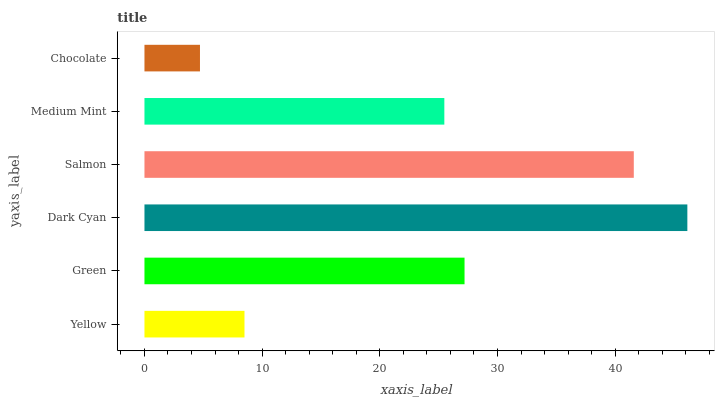Is Chocolate the minimum?
Answer yes or no. Yes. Is Dark Cyan the maximum?
Answer yes or no. Yes. Is Green the minimum?
Answer yes or no. No. Is Green the maximum?
Answer yes or no. No. Is Green greater than Yellow?
Answer yes or no. Yes. Is Yellow less than Green?
Answer yes or no. Yes. Is Yellow greater than Green?
Answer yes or no. No. Is Green less than Yellow?
Answer yes or no. No. Is Green the high median?
Answer yes or no. Yes. Is Medium Mint the low median?
Answer yes or no. Yes. Is Salmon the high median?
Answer yes or no. No. Is Yellow the low median?
Answer yes or no. No. 